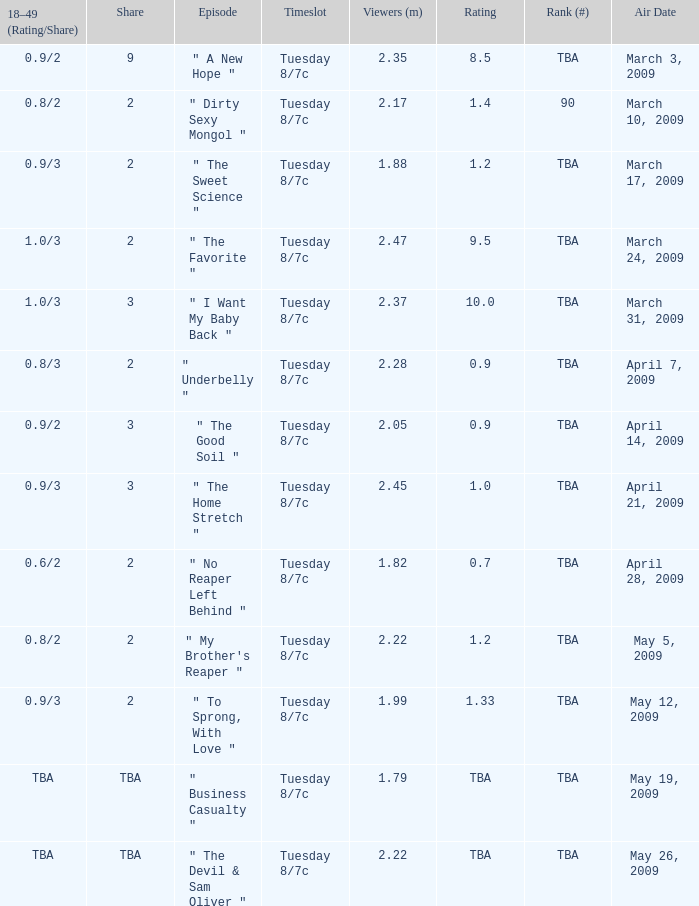What is the airing time for the episode that was on april 28, 2009? Tuesday 8/7c. 